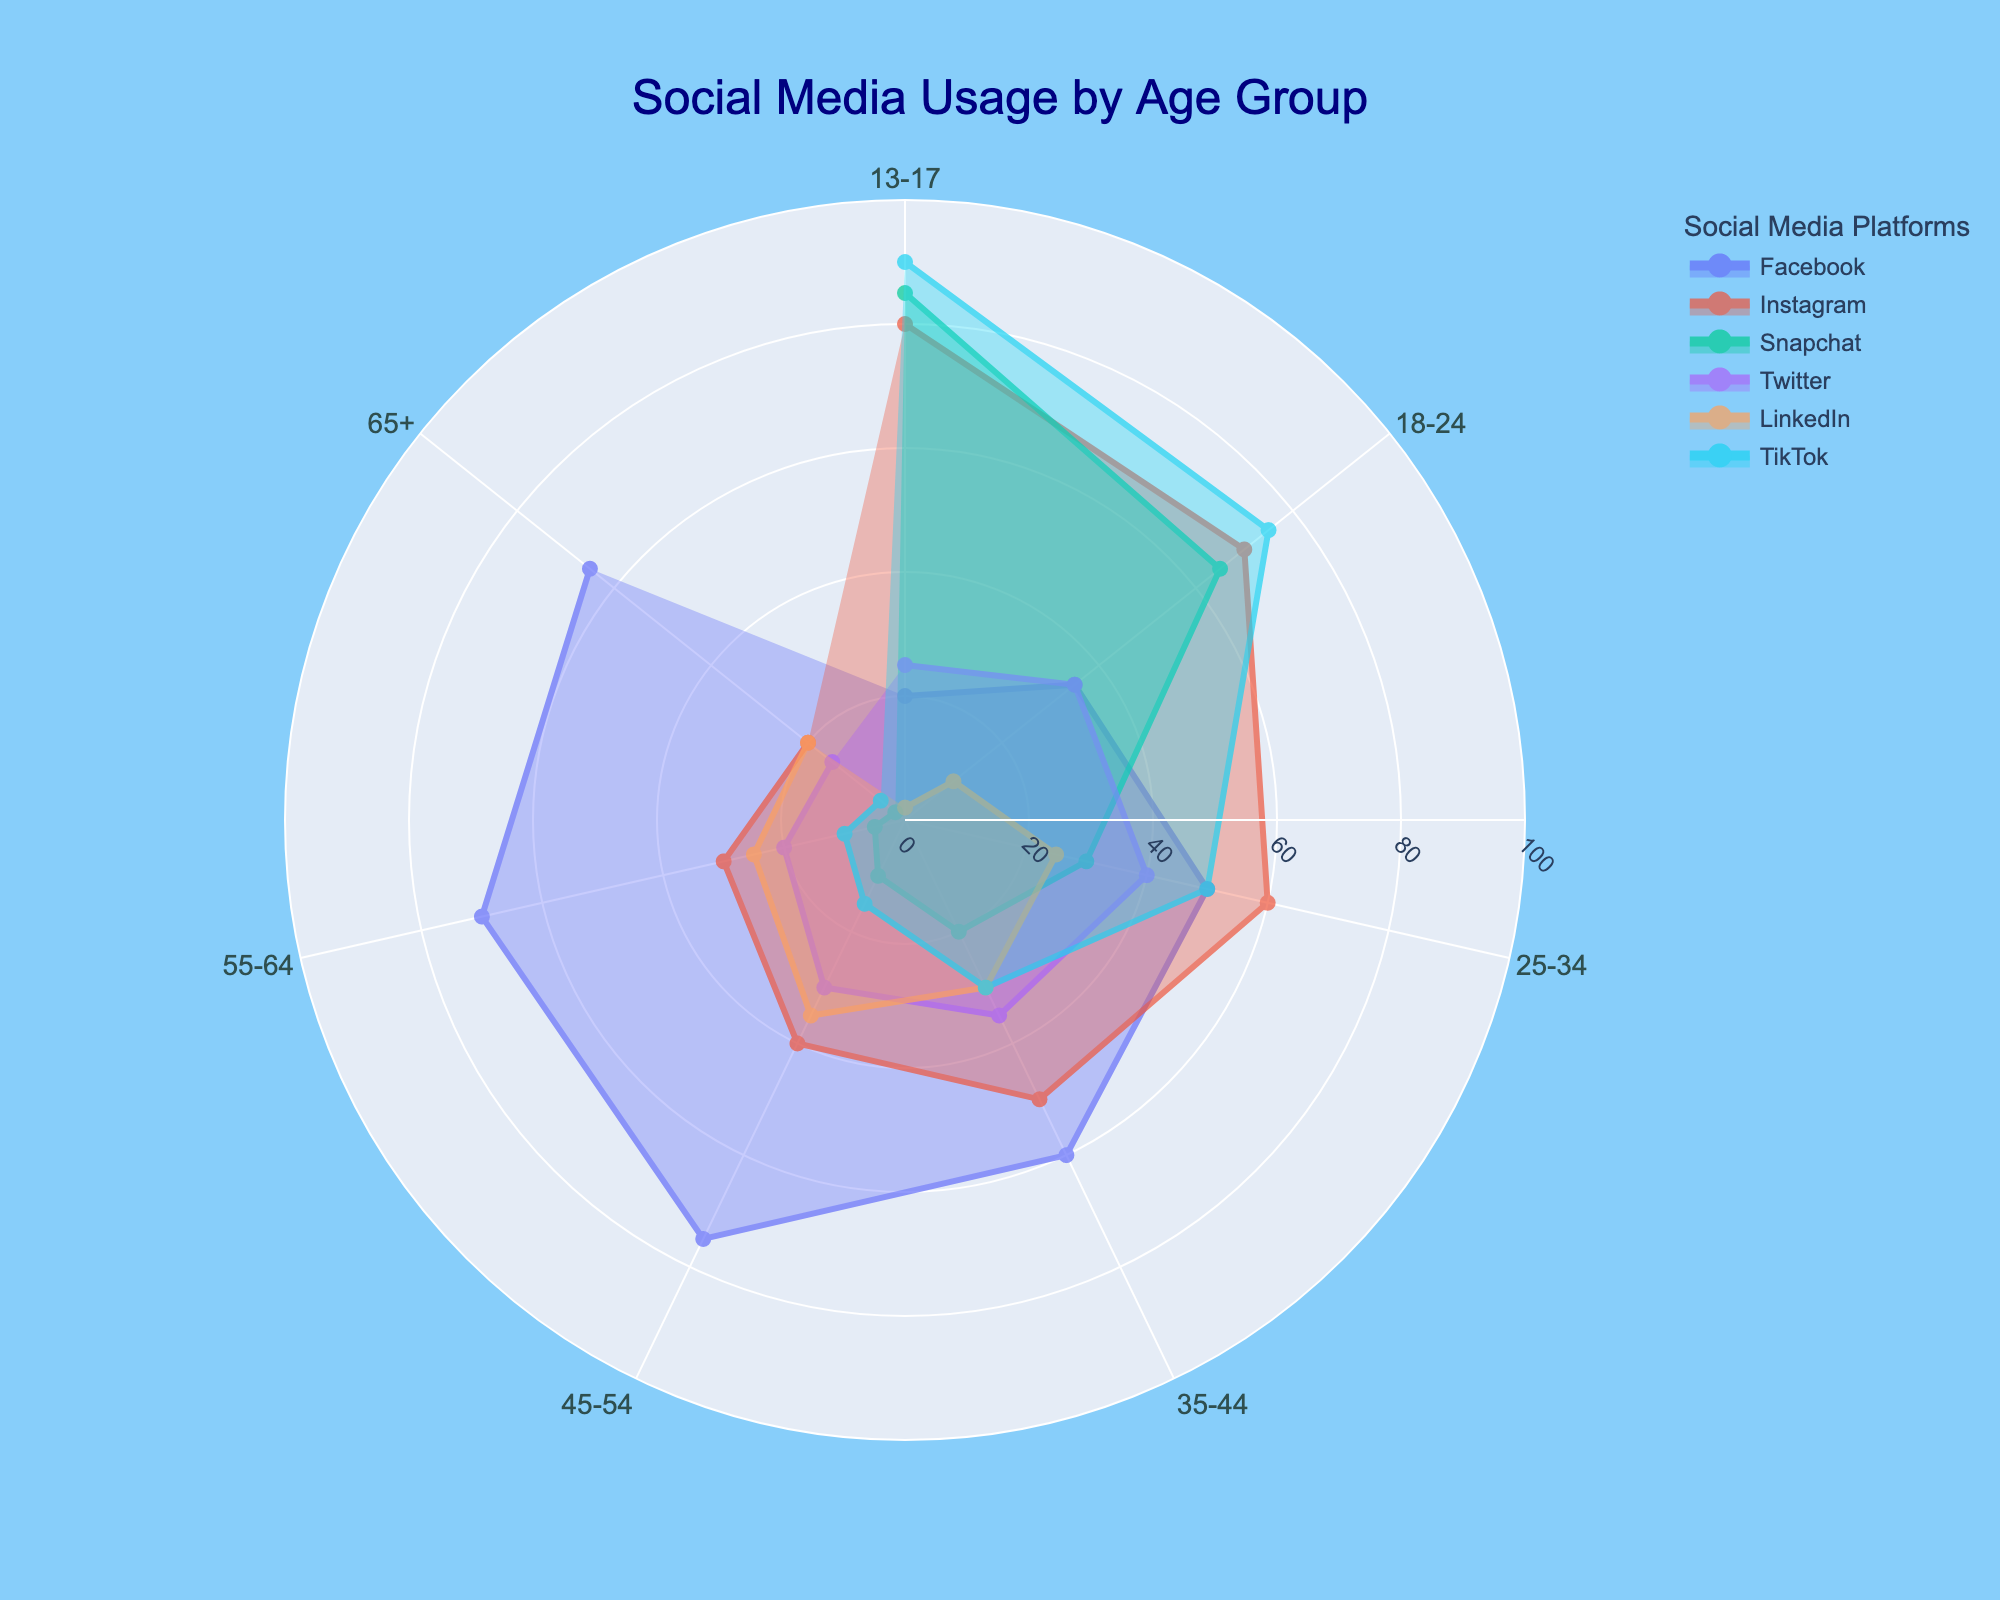What's the title of the figure? The title of the figure is usually displayed at the top of the plot. The figure shows this title prominently in a large font.
Answer: Social Media Usage by Age Group Which social media platform has the highest usage among the 13-17 age group? To find this, look at the point on the radial axis corresponding to the 13-17 age group for each platform. Identify which platform reaches the furthest out on the radial axis.
Answer: TikTok What is the range of Facebook usage across all age groups? Look at the minimum and maximum points on the radial axis for Facebook. The minimum value should be found in the lower age groups and the maximum in the higher ones.
Answer: 20 - 75 Which age group uses Instagram the most and which one the least? Identify the age group where the point on the radial axis for Instagram reaches the furthest and the least.
Answer: Most: 13-17, Least: 65+ How does Twitter usage compare between the 18-24 and 45-54 age groups? Look at the points on the radial axis for Twitter in the 18-24 and 45-54 age groups. Compare the values.
Answer: 18-24 is higher In terms of social media usage, which platform saw the most significant drop-off from the 13-17 to the 65+ age group? For each platform, subtract the usage percentage in the 65+ group from the 13-17 group. The platform with the highest difference has the most significant drop-off.
Answer: TikTok What is the average usage of LinkedIn across all age groups? Sum up the LinkedIn usage percentages for all age groups and divide by the number of age groups. (2+10+25+30+35+25+20)/7
Answer: 21 Which age group has the most balanced distribution of usage across all platforms? Examine each age group and look for relatively equal lengths of the radial distances. The group where the platforms resemble a more regular shape without one platform being disproportionately larger stands out.
Answer: 35-44 Is there a platform that consistently decreases in usage as age increases? Look at each platform's radial axis points from the youngest to oldest age groups. If the value keeps going down as age increases, it marks a consistent decrease.
Answer: Snapchat 